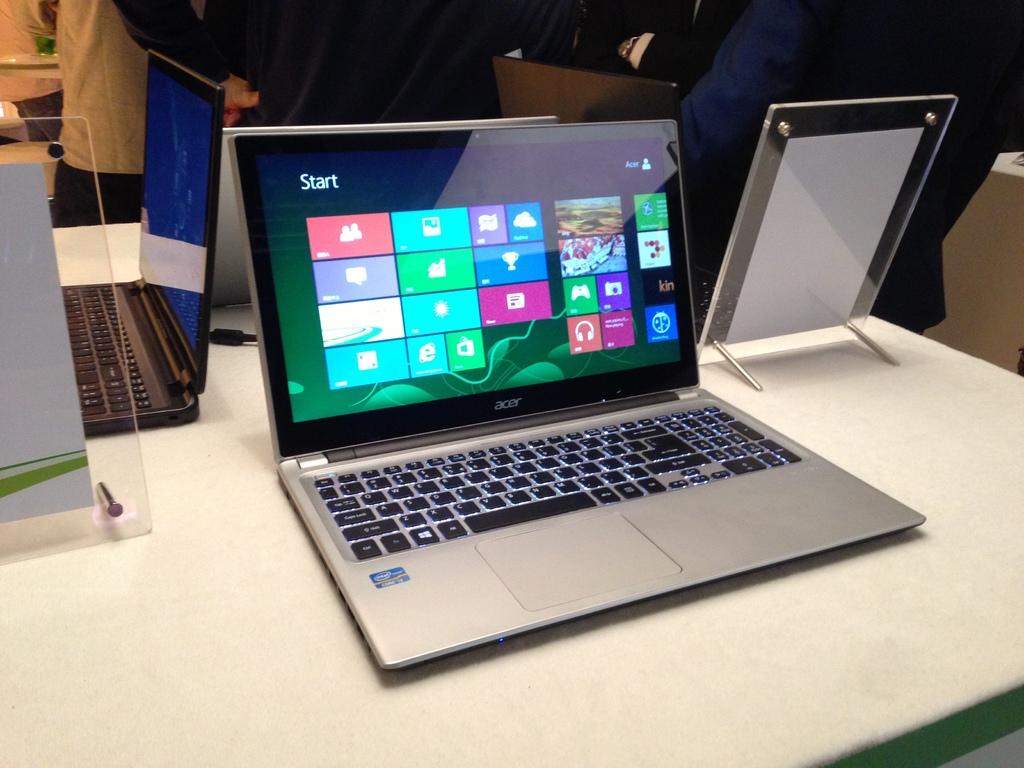<image>
Present a compact description of the photo's key features. Acer laptop that has a screen showing the Start panel. 